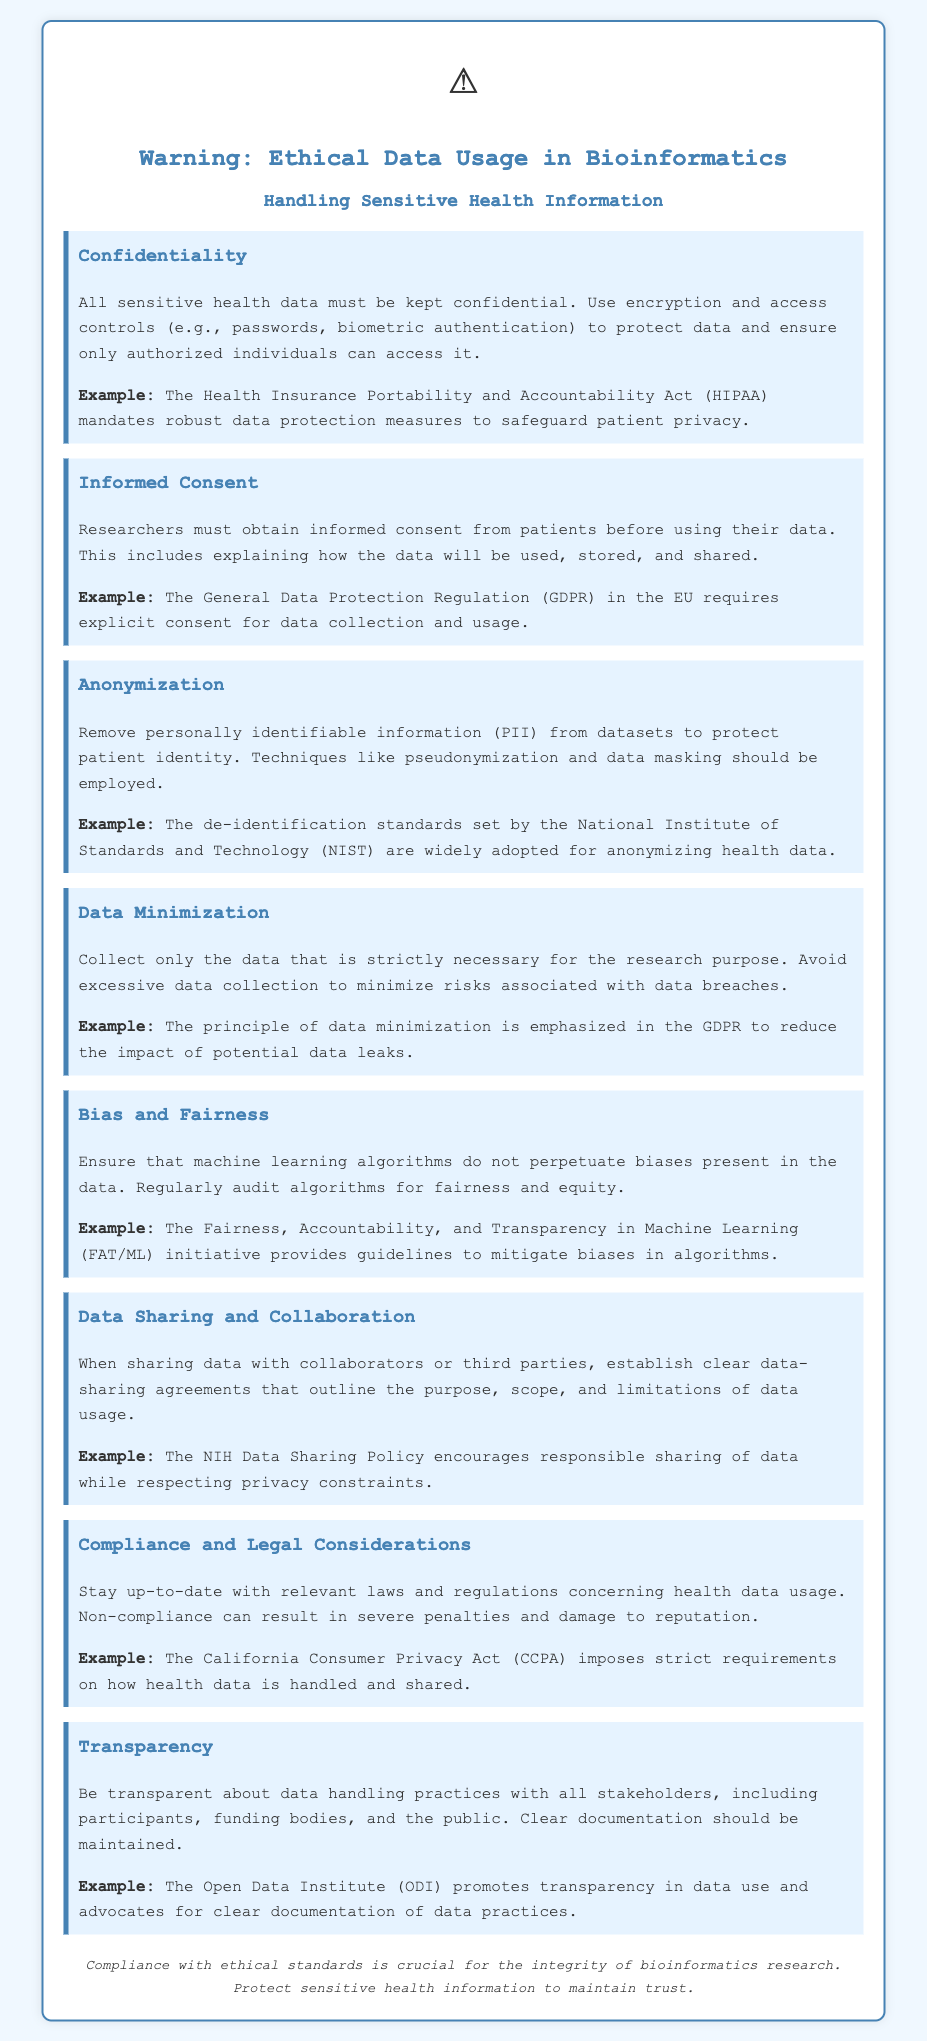What is the focus of the warning? The focus of the warning is about the ethical data usage specifically in the context of bioinformatics, highlighting the handling of sensitive health information.
Answer: Ethical Data Usage in Bioinformatics What is one method suggested for maintaining confidentiality? The document mentions using encryption and access controls as methods to maintain confidentiality of sensitive health data.
Answer: Encryption What is required before using patient data? The document specifies that researchers must obtain informed consent from patients before using their data, including an explanation of data use.
Answer: Informed consent What does the principle of data minimization emphasize? The principle emphasizes collecting only the data that is strictly necessary for the research purpose.
Answer: Collect only necessary data What is a recommended technique for protecting patient identity? The document suggests using techniques like pseudonymization and data masking to protect patient identity.
Answer: Pseudonymization Which act mandates robust data protection measures? The document mentions the Health Insurance Portability and Accountability Act (HIPAA) as an act that mandates robust data protection measures.
Answer: HIPAA What is emphasized by the General Data Protection Regulation (GDPR)? The General Data Protection Regulation emphasizes the need for explicit consent for data collection and usage.
Answer: Explicit consent What should be established when sharing data with third parties? The document recommends establishing clear data-sharing agreements when sharing data with third parties.
Answer: Data-sharing agreements Which initiative provides guidelines to mitigate biases in algorithms? The Fairness, Accountability, and Transparency in Machine Learning (FAT/ML) initiative provides guidelines to mitigate biases.
Answer: FAT/ML 